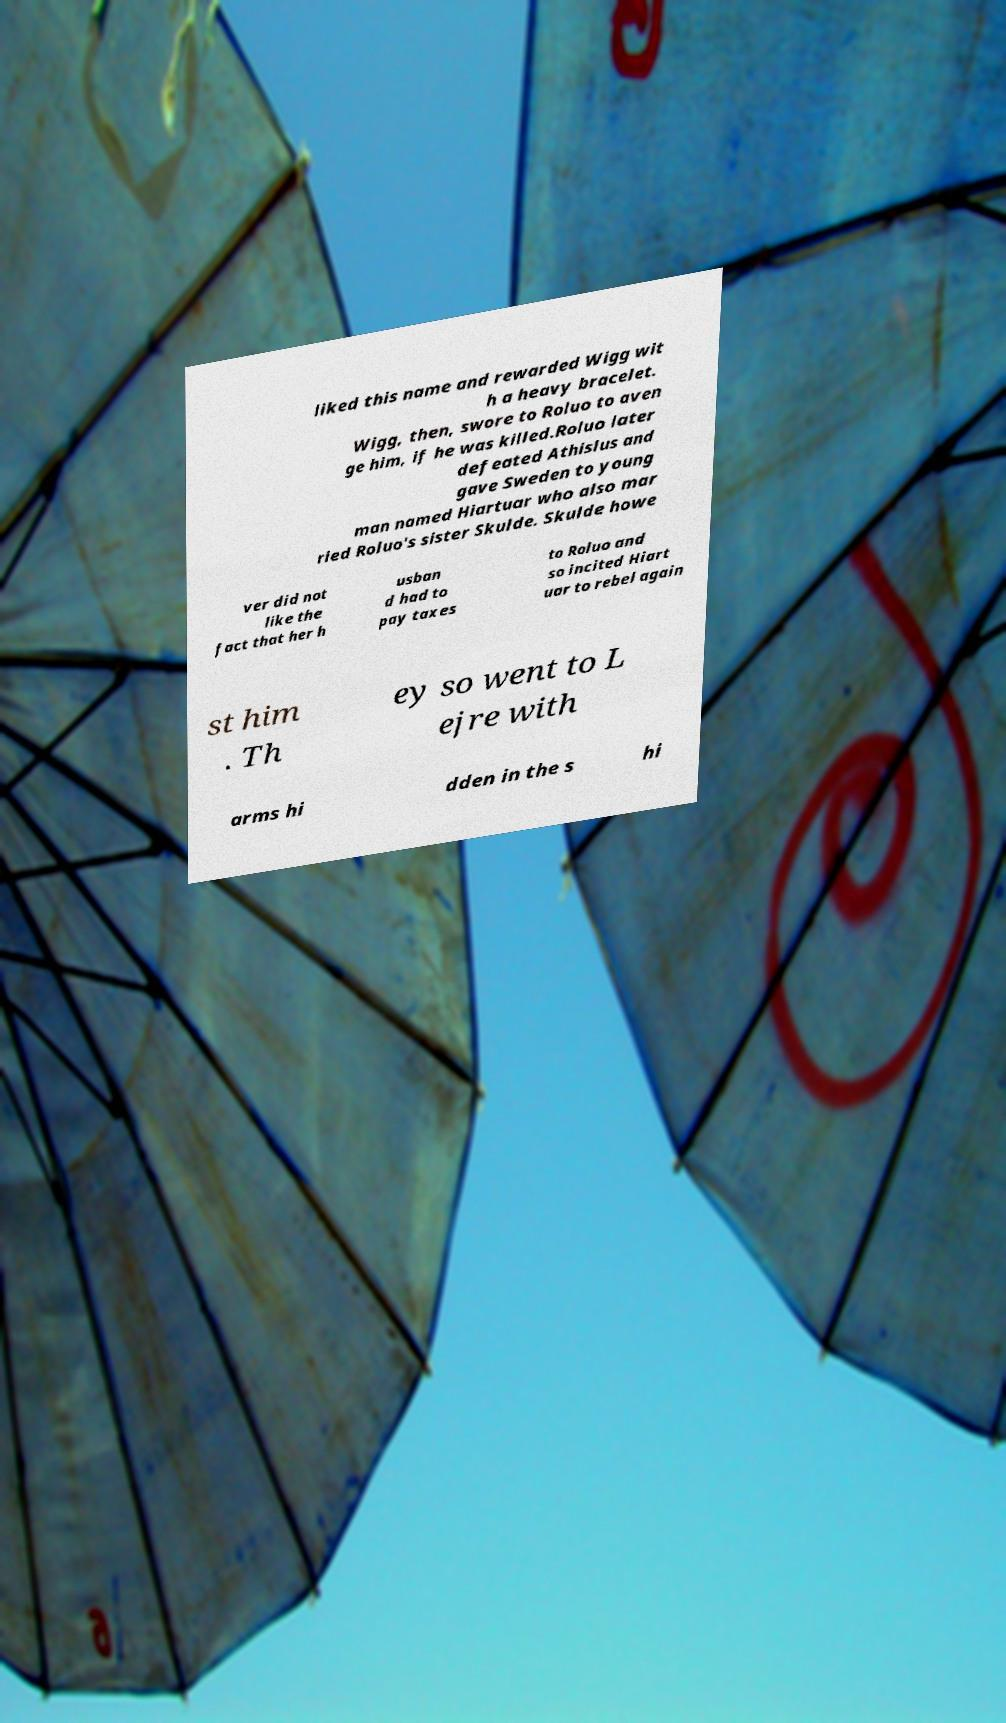Could you extract and type out the text from this image? liked this name and rewarded Wigg wit h a heavy bracelet. Wigg, then, swore to Roluo to aven ge him, if he was killed.Roluo later defeated Athislus and gave Sweden to young man named Hiartuar who also mar ried Roluo's sister Skulde. Skulde howe ver did not like the fact that her h usban d had to pay taxes to Roluo and so incited Hiart uar to rebel again st him . Th ey so went to L ejre with arms hi dden in the s hi 